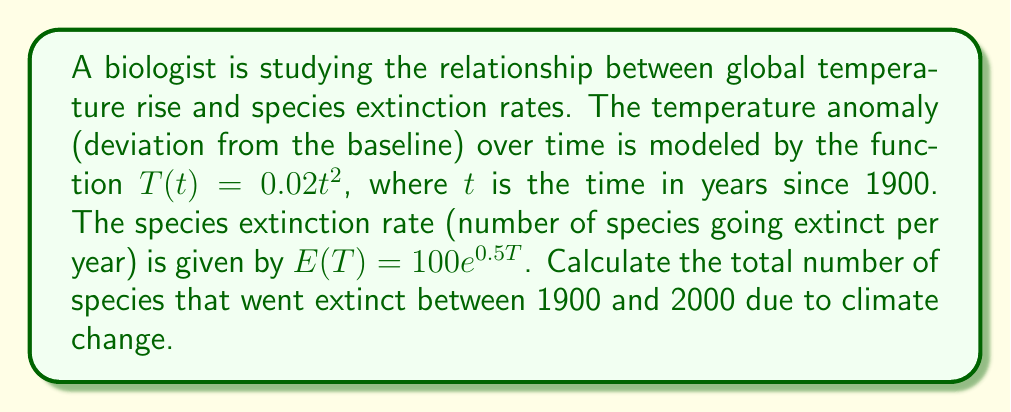Can you answer this question? To solve this problem, we need to follow these steps:

1) First, we need to express the extinction rate as a function of time:
   $E(t) = E(T(t)) = 100e^{0.5(0.02t^2)} = 100e^{0.01t^2}$

2) The total number of extinct species over the 100-year period is the integral of the extinction rate function from 0 to 100:

   $$N = \int_0^{100} E(t) dt = \int_0^{100} 100e^{0.01t^2} dt$$

3) This integral doesn't have an elementary antiderivative, so we need to use numerical integration. We can use the trapezoidal rule with a large number of subintervals for a good approximation.

4) Let's divide the interval [0, 100] into 1000 subintervals. The trapezoidal rule is:

   $$\int_a^b f(x) dx \approx \frac{b-a}{2n} [f(a) + 2f(x_1) + 2f(x_2) + ... + 2f(x_{n-1}) + f(b)]$$

   where $n$ is the number of subintervals and $x_i = a + i\frac{b-a}{n}$

5) Implementing this in a programming language (e.g., Python) would give us the approximate result:

   N ≈ 16,862 species

This means approximately 16,862 species went extinct due to climate change between 1900 and 2000 according to this model.
Answer: 16,862 species 